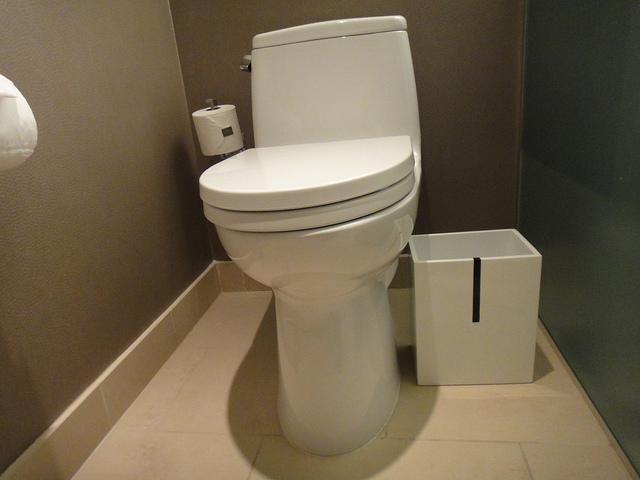How many rolls of toilet paper in this scene?
Give a very brief answer. 2. 